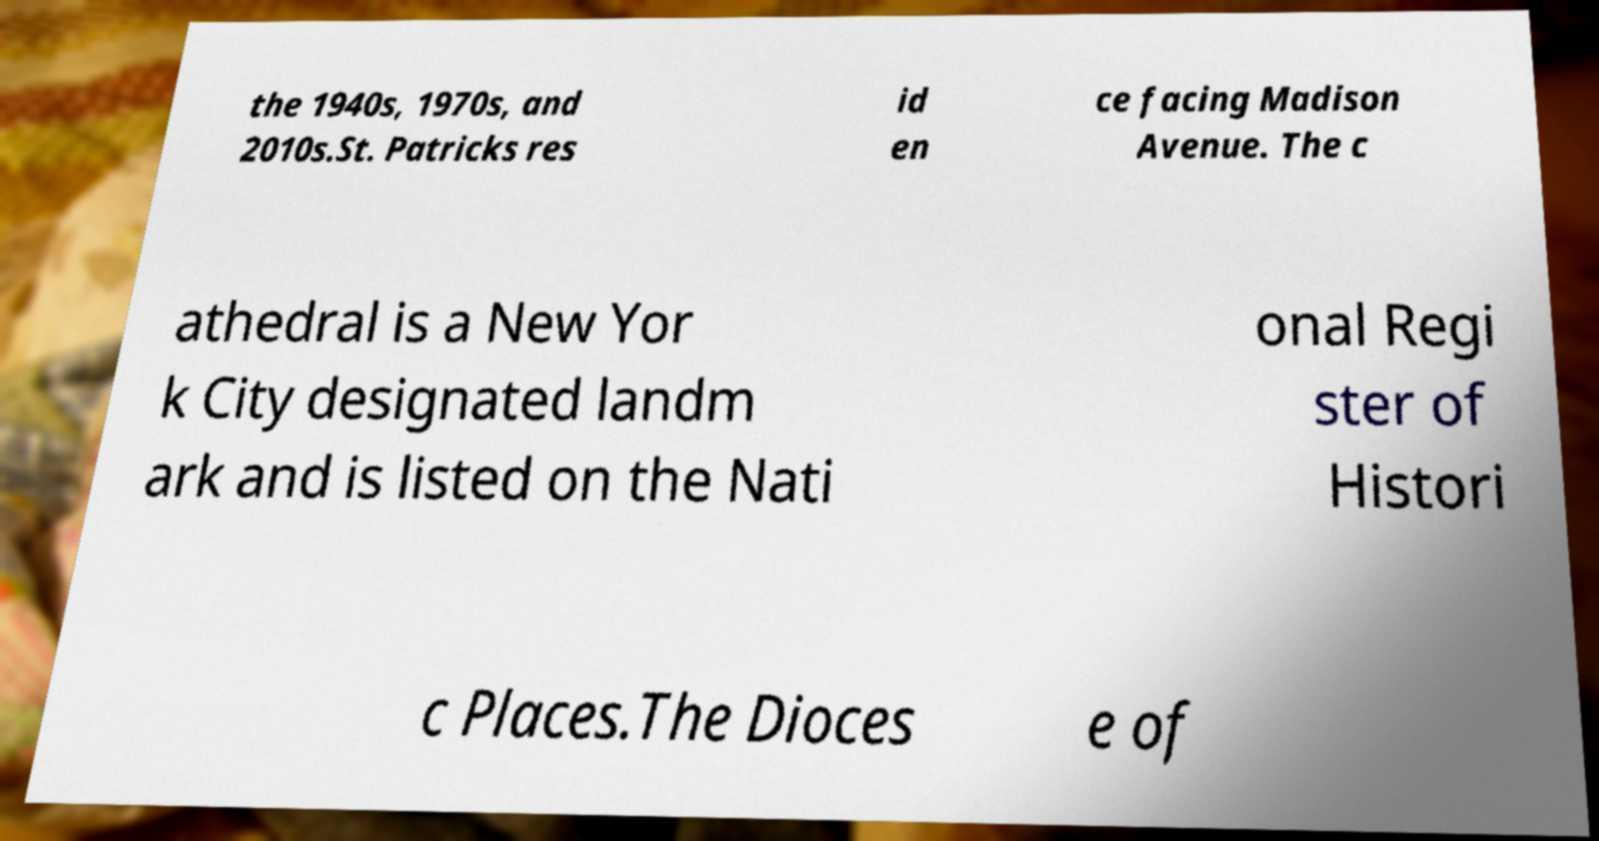Please read and relay the text visible in this image. What does it say? the 1940s, 1970s, and 2010s.St. Patricks res id en ce facing Madison Avenue. The c athedral is a New Yor k City designated landm ark and is listed on the Nati onal Regi ster of Histori c Places.The Dioces e of 